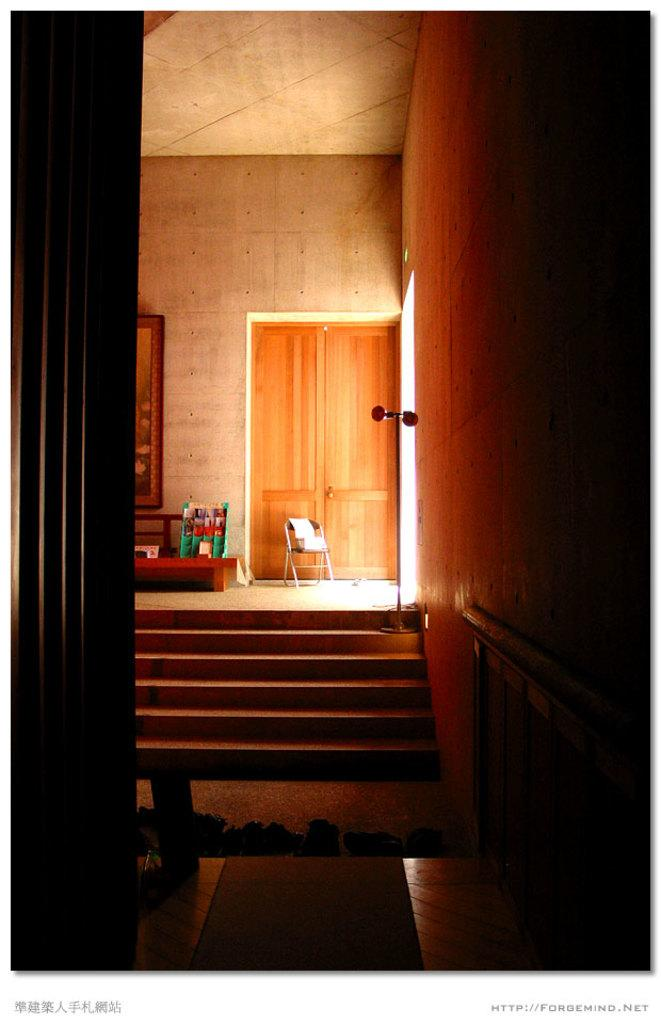What type of structure is present in the image? There is a staircase in the image. What feature is present alongside the staircase? There is a railing in the image. What material is visible in the image? There is glass in the image. What type of entrance is shown in the image? There is a door in the image. What decorative item can be seen in the image? There is a wall hanging in the image. What type of furniture is on the floor in the image? There is a chair on the floor in the image. What type of test is being conducted in the image? There is no test or any indication of a test being conducted in the image. Is the person in the image driving a vehicle? There is no person or vehicle present in the image. 